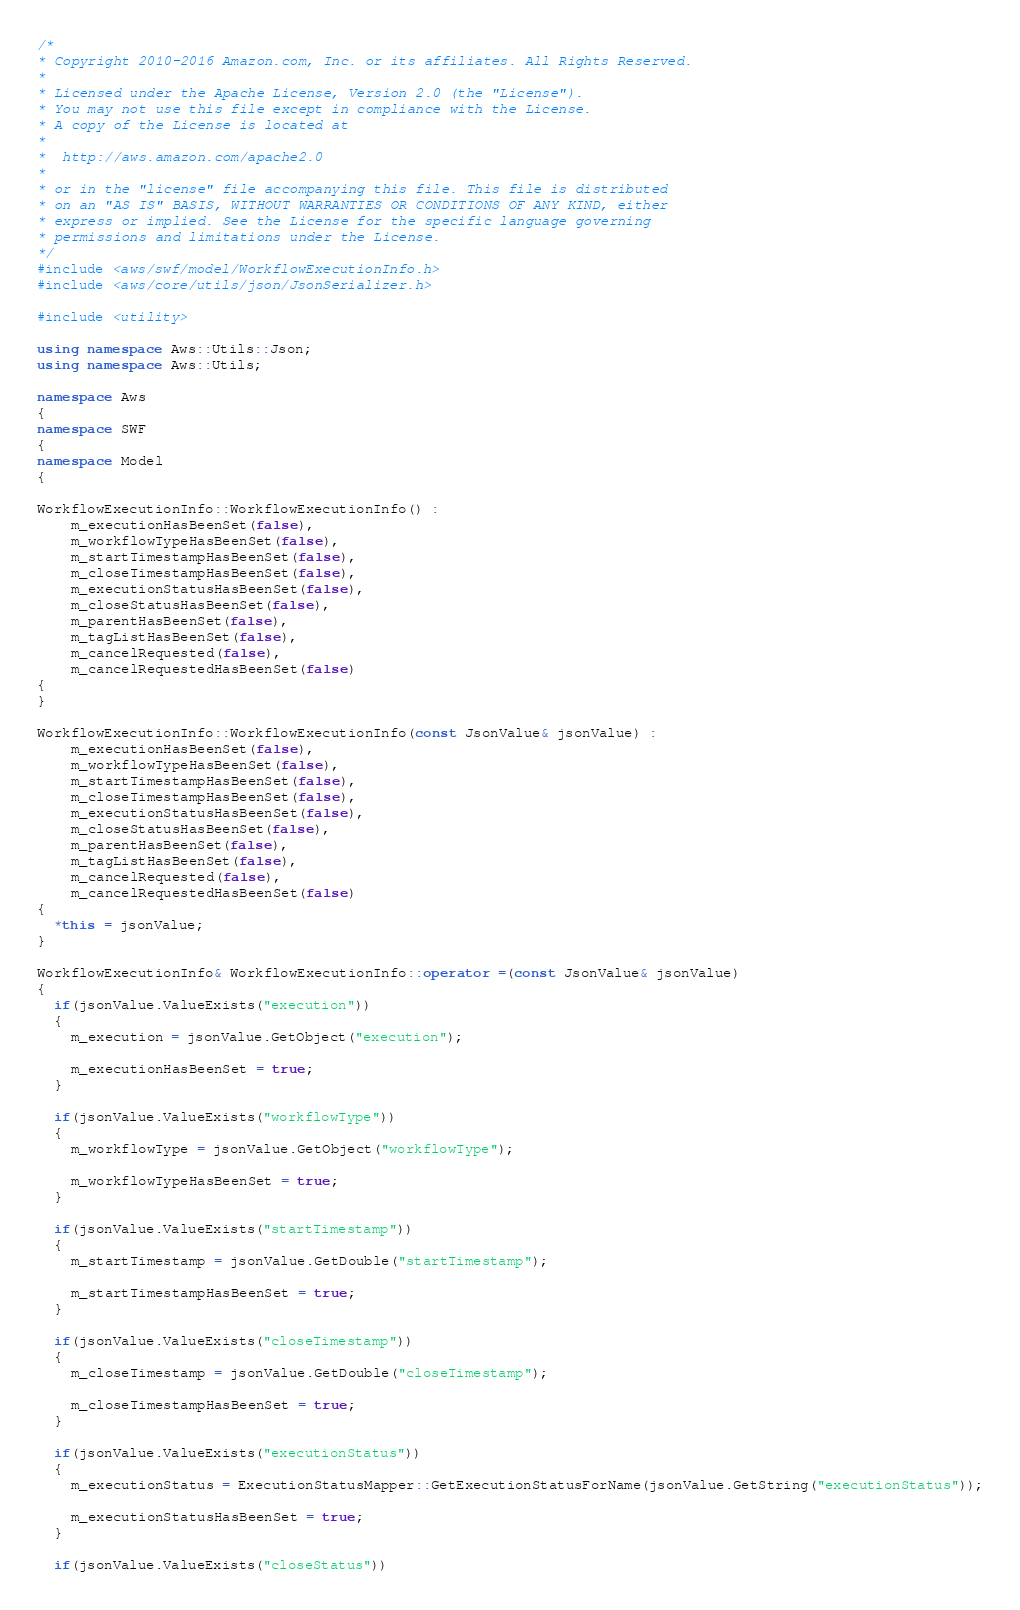Convert code to text. <code><loc_0><loc_0><loc_500><loc_500><_C++_>/*
* Copyright 2010-2016 Amazon.com, Inc. or its affiliates. All Rights Reserved.
*
* Licensed under the Apache License, Version 2.0 (the "License").
* You may not use this file except in compliance with the License.
* A copy of the License is located at
*
*  http://aws.amazon.com/apache2.0
*
* or in the "license" file accompanying this file. This file is distributed
* on an "AS IS" BASIS, WITHOUT WARRANTIES OR CONDITIONS OF ANY KIND, either
* express or implied. See the License for the specific language governing
* permissions and limitations under the License.
*/
#include <aws/swf/model/WorkflowExecutionInfo.h>
#include <aws/core/utils/json/JsonSerializer.h>

#include <utility>

using namespace Aws::Utils::Json;
using namespace Aws::Utils;

namespace Aws
{
namespace SWF
{
namespace Model
{

WorkflowExecutionInfo::WorkflowExecutionInfo() : 
    m_executionHasBeenSet(false),
    m_workflowTypeHasBeenSet(false),
    m_startTimestampHasBeenSet(false),
    m_closeTimestampHasBeenSet(false),
    m_executionStatusHasBeenSet(false),
    m_closeStatusHasBeenSet(false),
    m_parentHasBeenSet(false),
    m_tagListHasBeenSet(false),
    m_cancelRequested(false),
    m_cancelRequestedHasBeenSet(false)
{
}

WorkflowExecutionInfo::WorkflowExecutionInfo(const JsonValue& jsonValue) : 
    m_executionHasBeenSet(false),
    m_workflowTypeHasBeenSet(false),
    m_startTimestampHasBeenSet(false),
    m_closeTimestampHasBeenSet(false),
    m_executionStatusHasBeenSet(false),
    m_closeStatusHasBeenSet(false),
    m_parentHasBeenSet(false),
    m_tagListHasBeenSet(false),
    m_cancelRequested(false),
    m_cancelRequestedHasBeenSet(false)
{
  *this = jsonValue;
}

WorkflowExecutionInfo& WorkflowExecutionInfo::operator =(const JsonValue& jsonValue)
{
  if(jsonValue.ValueExists("execution"))
  {
    m_execution = jsonValue.GetObject("execution");

    m_executionHasBeenSet = true;
  }

  if(jsonValue.ValueExists("workflowType"))
  {
    m_workflowType = jsonValue.GetObject("workflowType");

    m_workflowTypeHasBeenSet = true;
  }

  if(jsonValue.ValueExists("startTimestamp"))
  {
    m_startTimestamp = jsonValue.GetDouble("startTimestamp");

    m_startTimestampHasBeenSet = true;
  }

  if(jsonValue.ValueExists("closeTimestamp"))
  {
    m_closeTimestamp = jsonValue.GetDouble("closeTimestamp");

    m_closeTimestampHasBeenSet = true;
  }

  if(jsonValue.ValueExists("executionStatus"))
  {
    m_executionStatus = ExecutionStatusMapper::GetExecutionStatusForName(jsonValue.GetString("executionStatus"));

    m_executionStatusHasBeenSet = true;
  }

  if(jsonValue.ValueExists("closeStatus"))</code> 